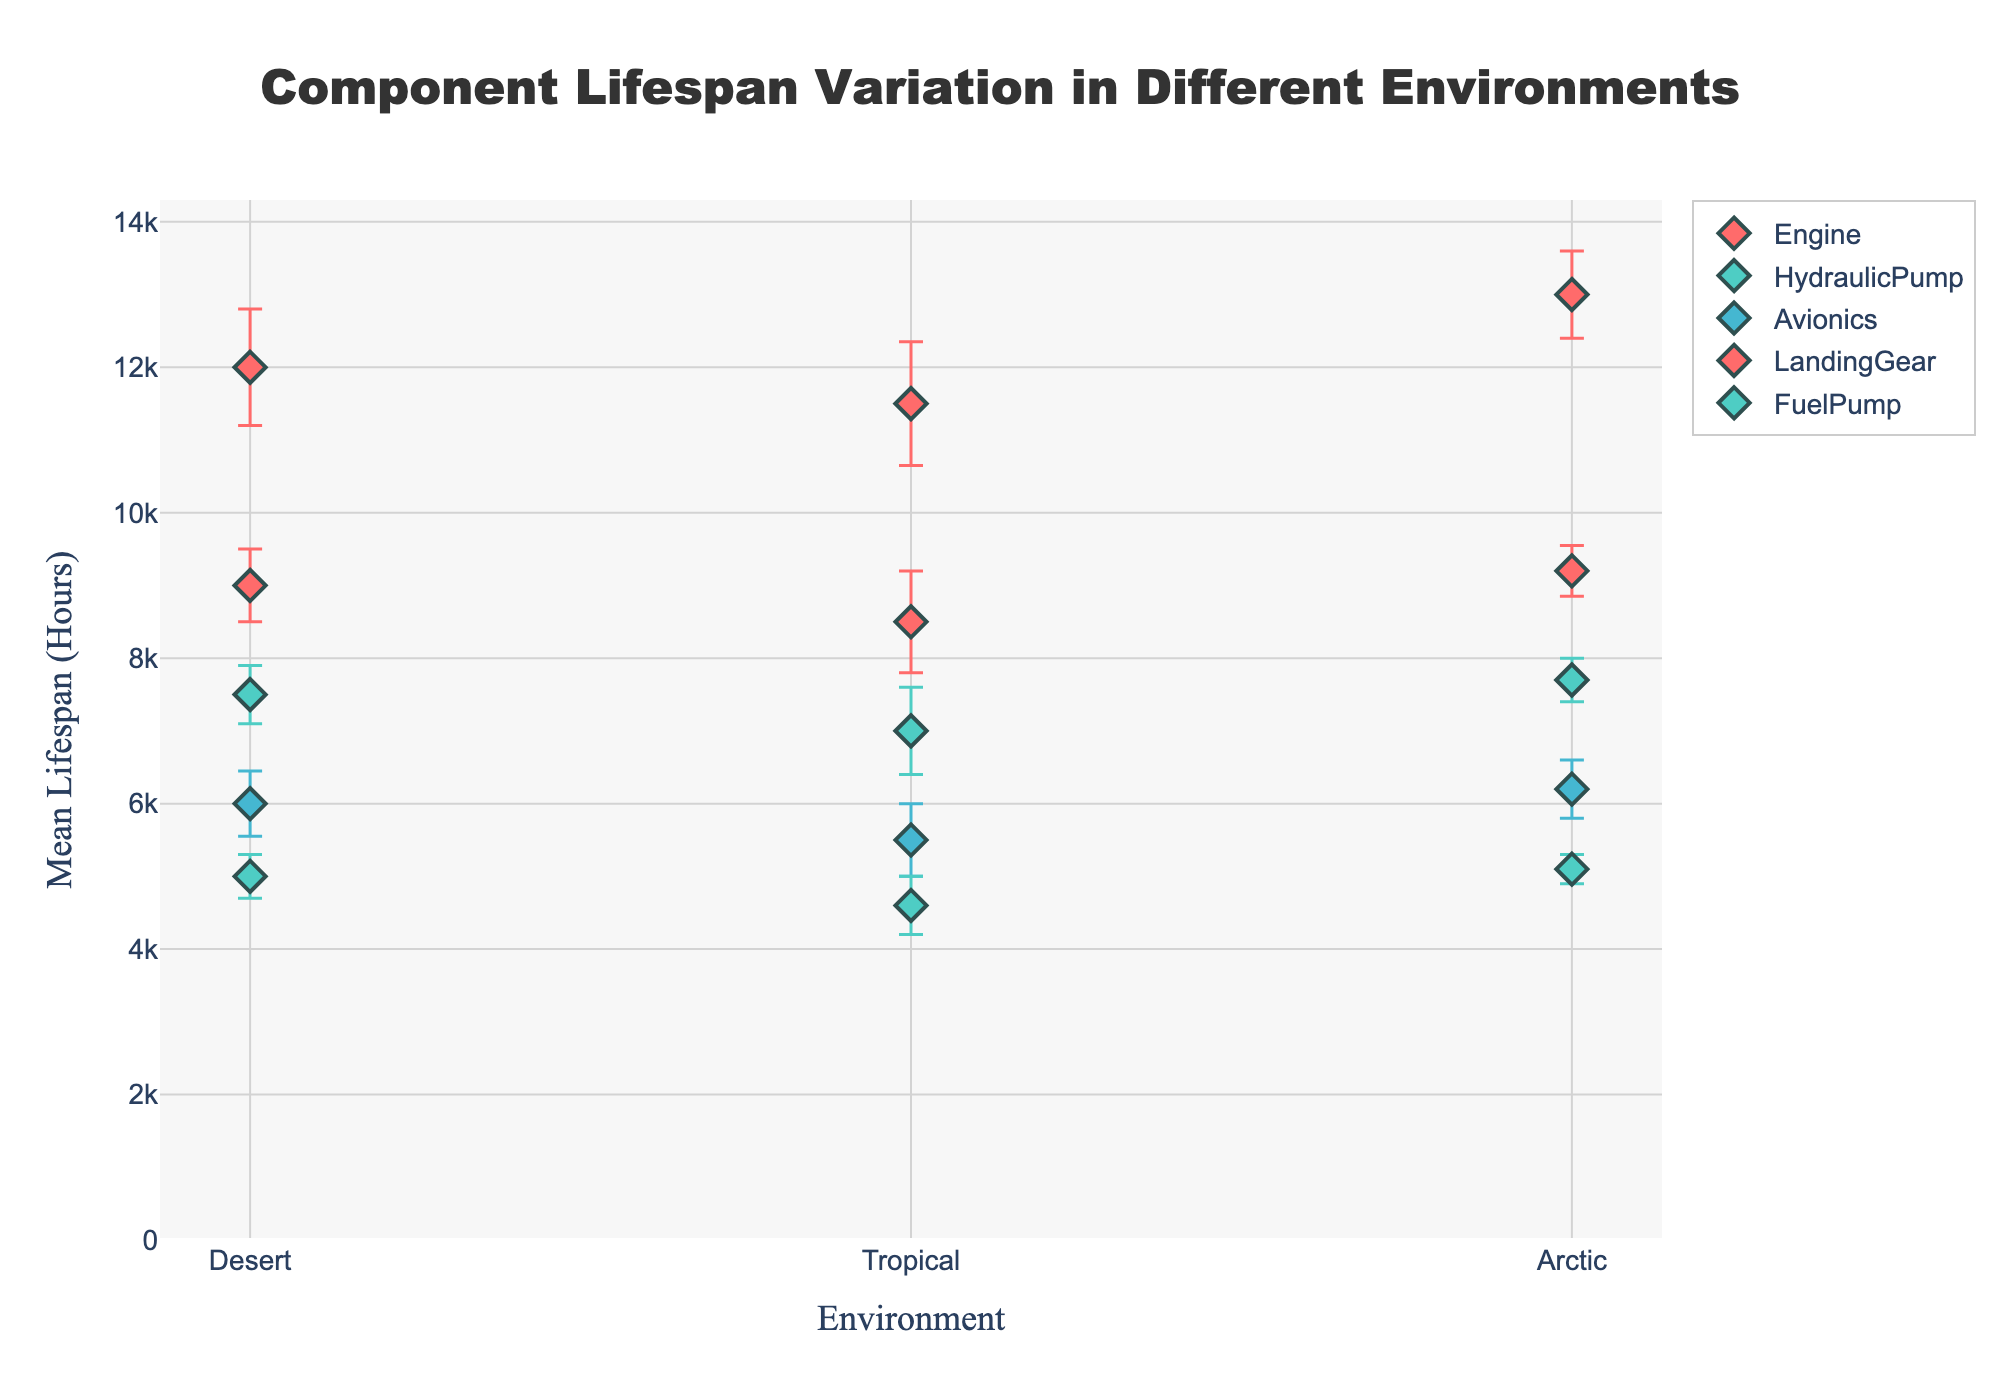What are the mean lifespans of the Engine in different environments? The mean lifespans for the Engine in different environments can be read directly from the plot. In the Desert, it's 9000 hours, in Tropical, it's 8500 hours, and in the Arctic, it's 9200 hours.
Answer: Desert: 9000, Tropical: 8500, Arctic: 9200 Which component has the highest mean lifespan in the Tropical environment? By examining the plot, we see that in the Tropical environment, the LandingGear has the highest mean lifespan with 11500 hours.
Answer: LandingGear How does the average lifespan of the Hydraulic Pump in the Desert compare to that in the Arctic? Refer to the plot for the mean lifespans: Desert is 7500 hours and Arctic is 7700 hours. Subtract the Desert lifespan from the Arctic lifespan to find the difference.
Answer: Arctic is 200 hours more Which component shows the largest variability in lifespan in the Tropical environment? Variability is represented by the error bars. The component with the longest error bars in the Tropical environment is the LandingGear with 850 hours.
Answer: LandingGear What is the mean lifespan of the Avionics across all environments? Add up the mean lifespans from each environment and divide by the number of environments (Desert: 6000, Tropical: 5500, Arctic: 6200). Sum is 17700 hours, divide by 3.
Answer: 5900 In which environment does the Fuel Pump have the lowest standard deviation in lifespan? Refer to the error bars of the Fuel Pump in each environment. The Arctic has the shortest error bar of 200 hours.
Answer: Arctic Which environment sees the largest difference in mean lifespans between the LandingGear and Avionics? Calculate the differences in each environment: Desert: 12000 - 6000, Tropical: 11500 - 5500, Arctic: 13000 - 6200. The largest difference is in the Arctic (6800).
Answer: Arctic What is the range of mean lifespans for all components in the Desert environment? Identify the minimum and maximum mean lifespans in the Desert: Fuel Pump (5000) and LandingGear (12000). Subtract the minimum from the maximum.
Answer: 7000 How does the variability in the Engine's lifespan compare to that of the Fuel Pump across all environments? Compare the error bars for the Engine and Fuel Pump in each environment. The Engine has consistently longer error bars, indicating more variability.
Answer: Engine is more variable Which component has the least variation in lifespan in the Arctic environment, and what is its standard deviation? Look for the smallest error bar in the Arctic: Hydraulic Pump has the smallest error bar with a standard deviation of 300 hours.
Answer: HydraulicPump, 300 hours 